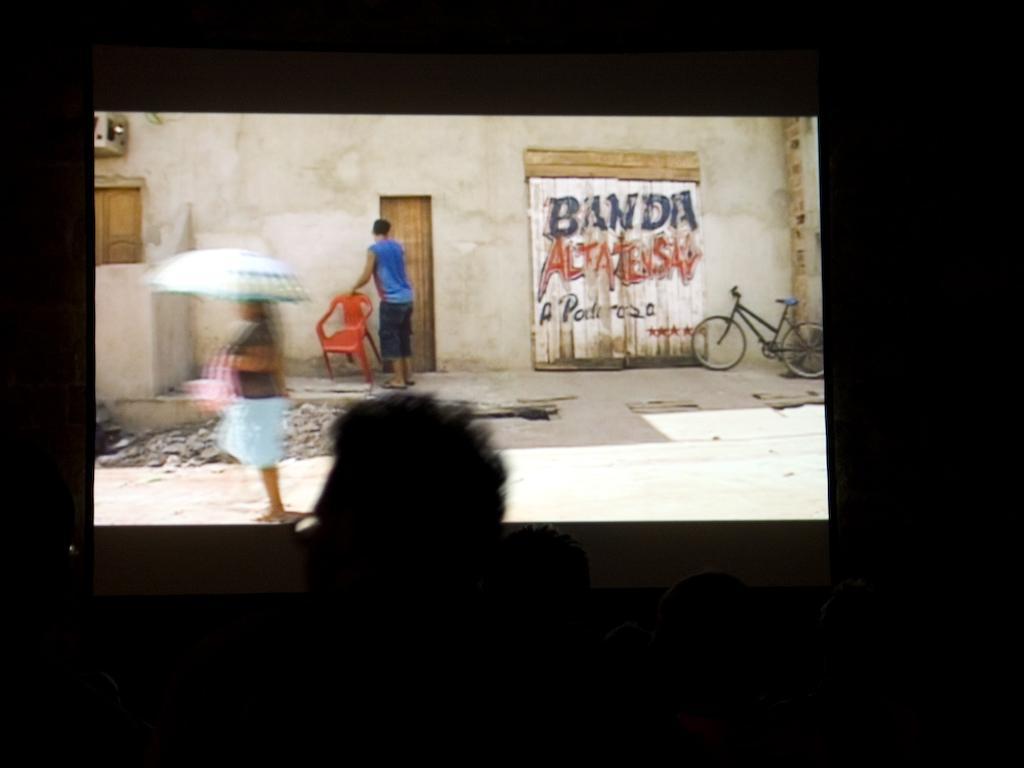Please provide a concise description of this image. The picture is taken in a theater. In the foreground the picture there are heads of people. In the center of the picture it is screen, in the screen there is a woman walking on the road. In the background there is a man holding a chair. iIt is a picture outside a city on the streets. Around the screen it is dark. 